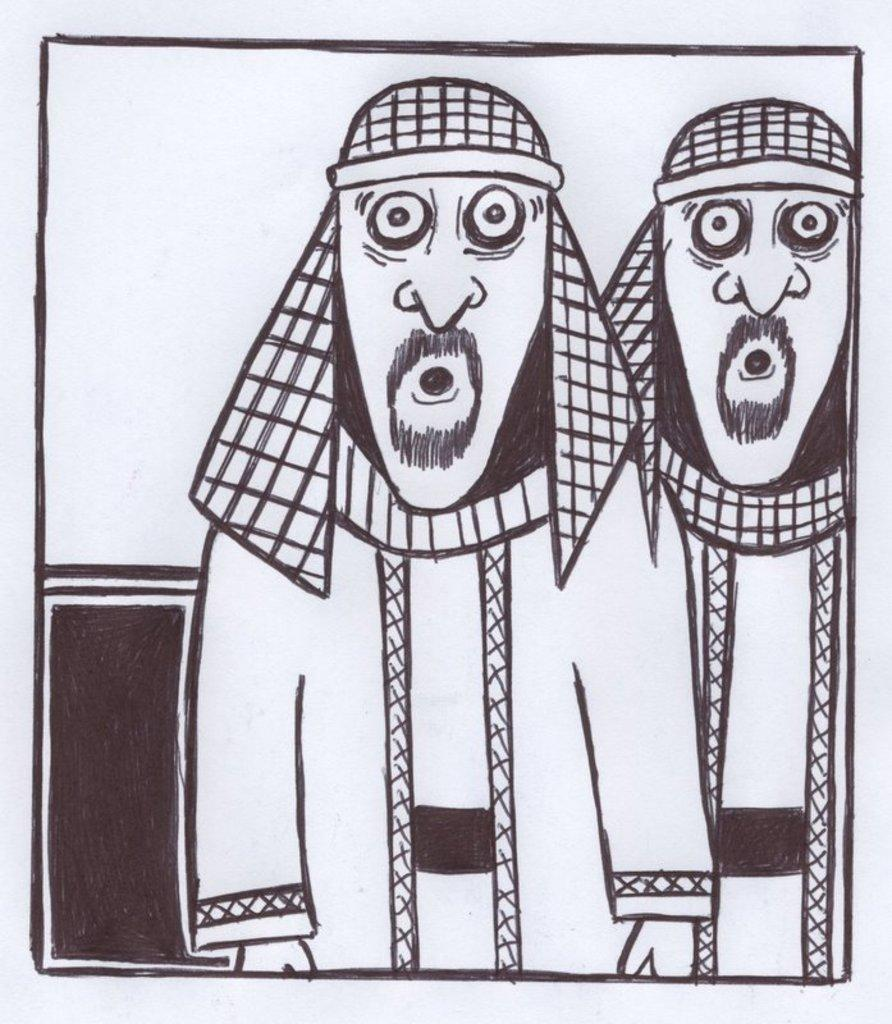What is depicted in the image? The image contains a sketch of two persons. What medium was used to create the sketch? The sketch is drawn using a black colored pen. What is the color of the surface on which the sketch is drawn? The sketch is drawn on a white colored surface. Where is the mailbox located in the image? There is no mailbox present in the image; it only contains a sketch of two persons. What type of balance is being maintained by the hen in the image? There is no hen present in the image; it only contains a sketch of two persons. 